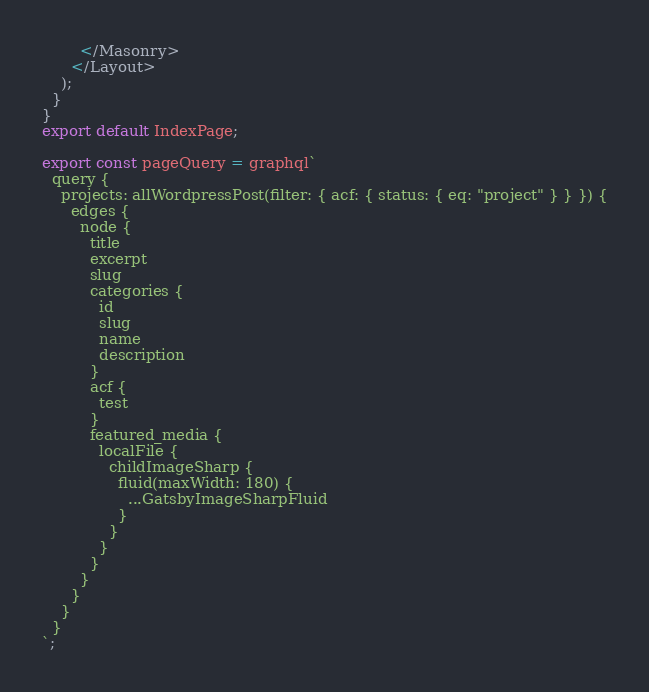<code> <loc_0><loc_0><loc_500><loc_500><_JavaScript_>        </Masonry>
      </Layout>
    );
  }
}
export default IndexPage;

export const pageQuery = graphql`
  query {
    projects: allWordpressPost(filter: { acf: { status: { eq: "project" } } }) {
      edges {
        node {
          title
          excerpt
          slug
          categories {
            id
            slug
            name
            description
          }
          acf {
            test
          }
          featured_media {
            localFile {
              childImageSharp {
                fluid(maxWidth: 180) {
                  ...GatsbyImageSharpFluid
                }
              }
            }
          }
        }
      }
    }
  }
`;
</code> 